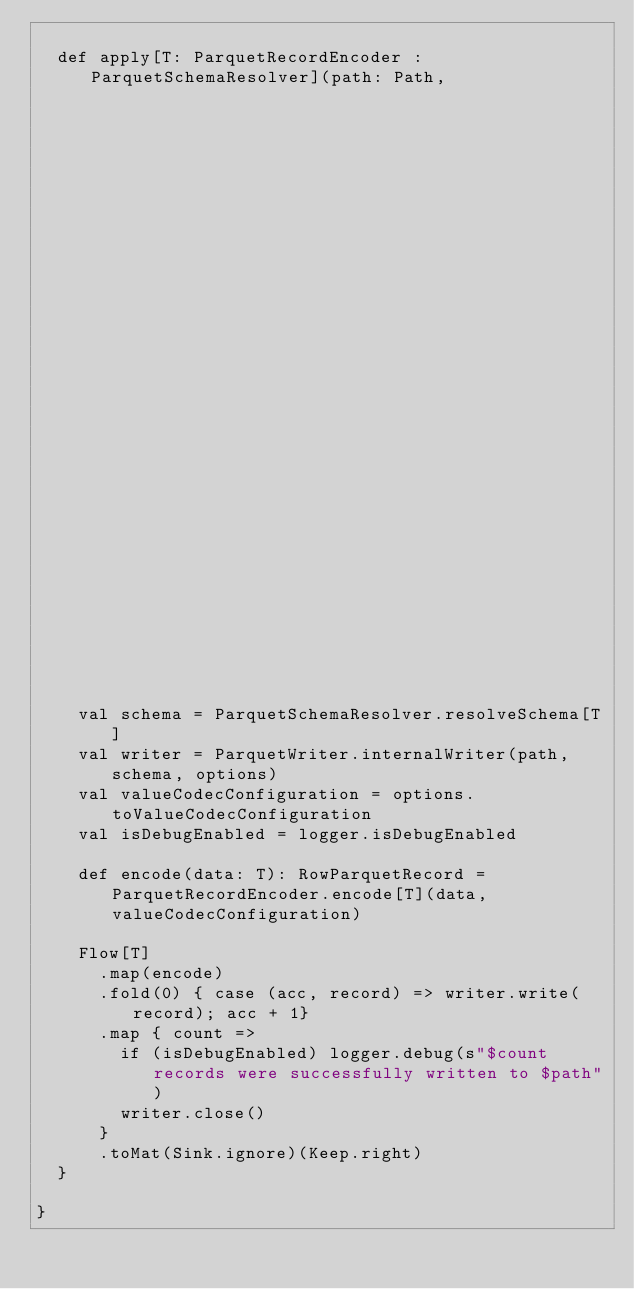Convert code to text. <code><loc_0><loc_0><loc_500><loc_500><_Scala_>
  def apply[T: ParquetRecordEncoder : ParquetSchemaResolver](path: Path,
                                                             options: ParquetWriter.Options = ParquetWriter.Options()
                                                            ): Sink[T, Future[Done]] = {
    val schema = ParquetSchemaResolver.resolveSchema[T]
    val writer = ParquetWriter.internalWriter(path, schema, options)
    val valueCodecConfiguration = options.toValueCodecConfiguration
    val isDebugEnabled = logger.isDebugEnabled

    def encode(data: T): RowParquetRecord = ParquetRecordEncoder.encode[T](data, valueCodecConfiguration)

    Flow[T]
      .map(encode)
      .fold(0) { case (acc, record) => writer.write(record); acc + 1}
      .map { count =>
        if (isDebugEnabled) logger.debug(s"$count records were successfully written to $path")
        writer.close()
      }
      .toMat(Sink.ignore)(Keep.right)
  }

}
</code> 